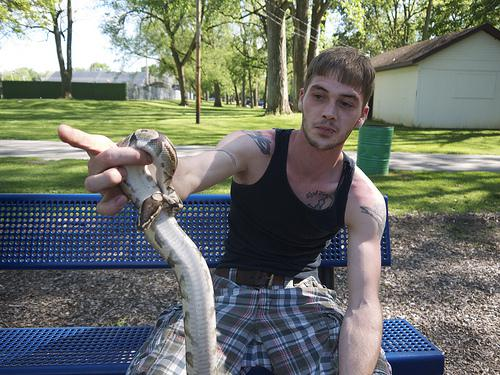Question: what animal is shown?
Choices:
A. A bear.
B. Snake.
C. A lizard.
D. A horse.
Answer with the letter. Answer: B Question: what color tank top is there?
Choices:
A. Black.
B. Red.
C. Brown.
D. White.
Answer with the letter. Answer: A Question: where is this shot at?
Choices:
A. Lake.
B. Mountain.
C. Forest.
D. Park.
Answer with the letter. Answer: D Question: how many cars are shown?
Choices:
A. 1.
B. 0.
C. 3.
D. 2.
Answer with the letter. Answer: B 